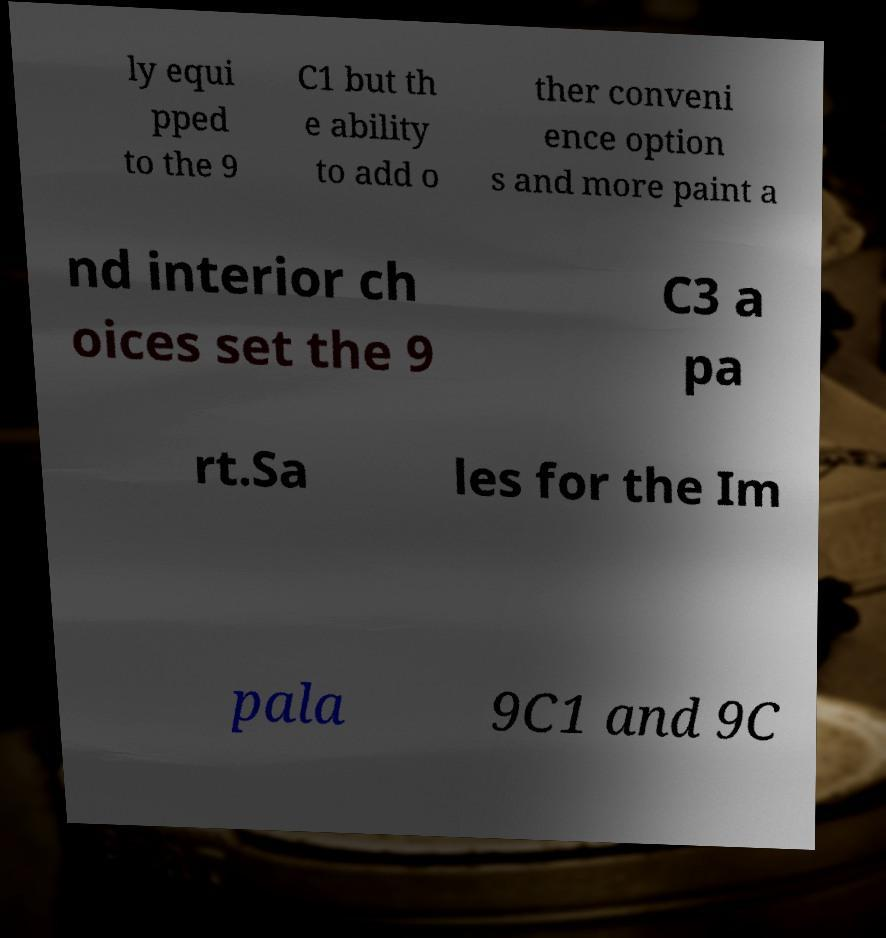There's text embedded in this image that I need extracted. Can you transcribe it verbatim? ly equi pped to the 9 C1 but th e ability to add o ther conveni ence option s and more paint a nd interior ch oices set the 9 C3 a pa rt.Sa les for the Im pala 9C1 and 9C 